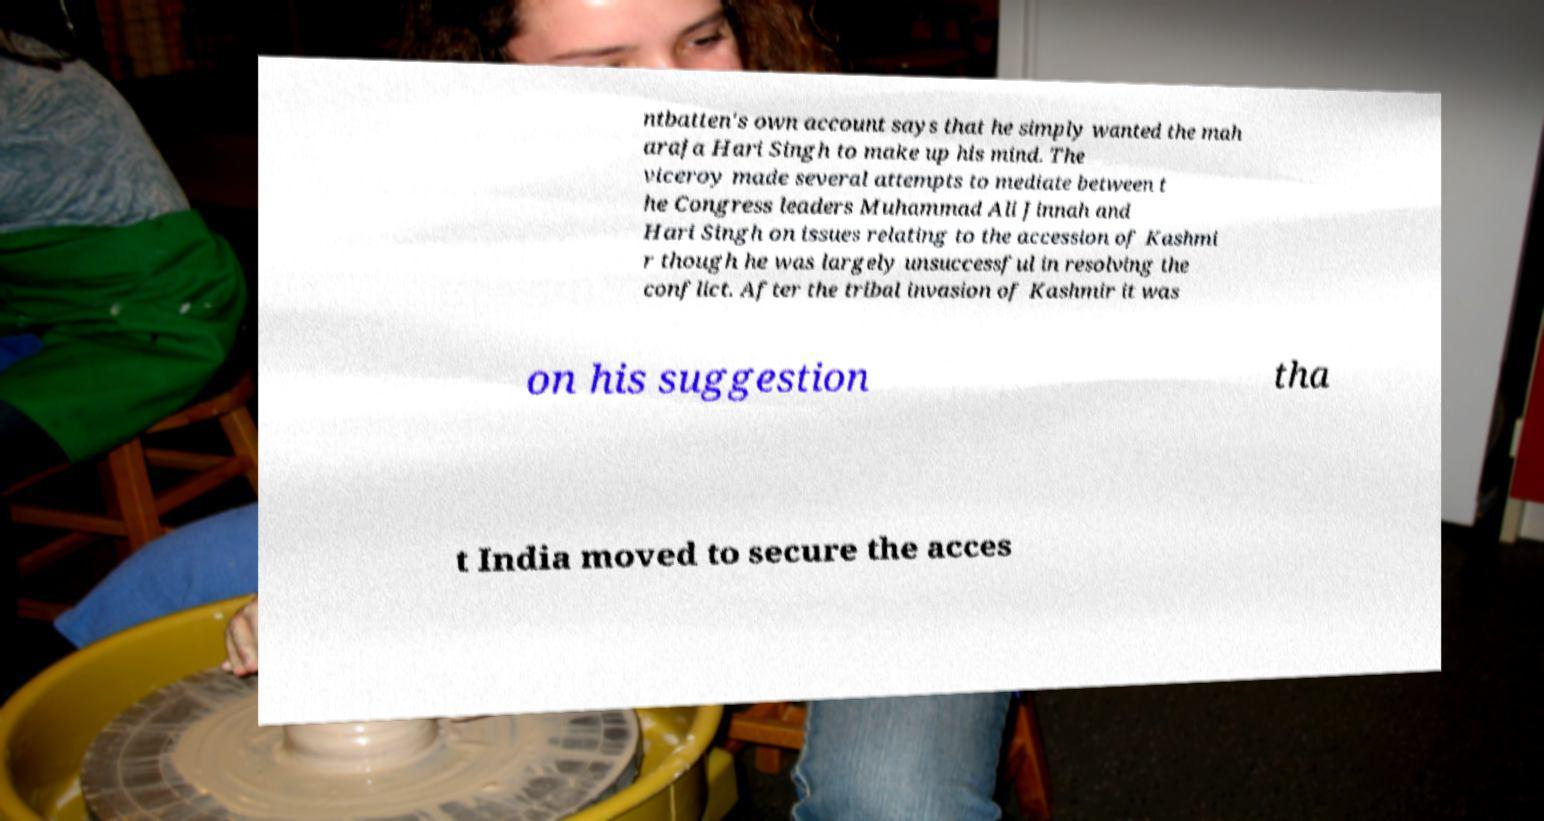Can you accurately transcribe the text from the provided image for me? ntbatten's own account says that he simply wanted the mah araja Hari Singh to make up his mind. The viceroy made several attempts to mediate between t he Congress leaders Muhammad Ali Jinnah and Hari Singh on issues relating to the accession of Kashmi r though he was largely unsuccessful in resolving the conflict. After the tribal invasion of Kashmir it was on his suggestion tha t India moved to secure the acces 